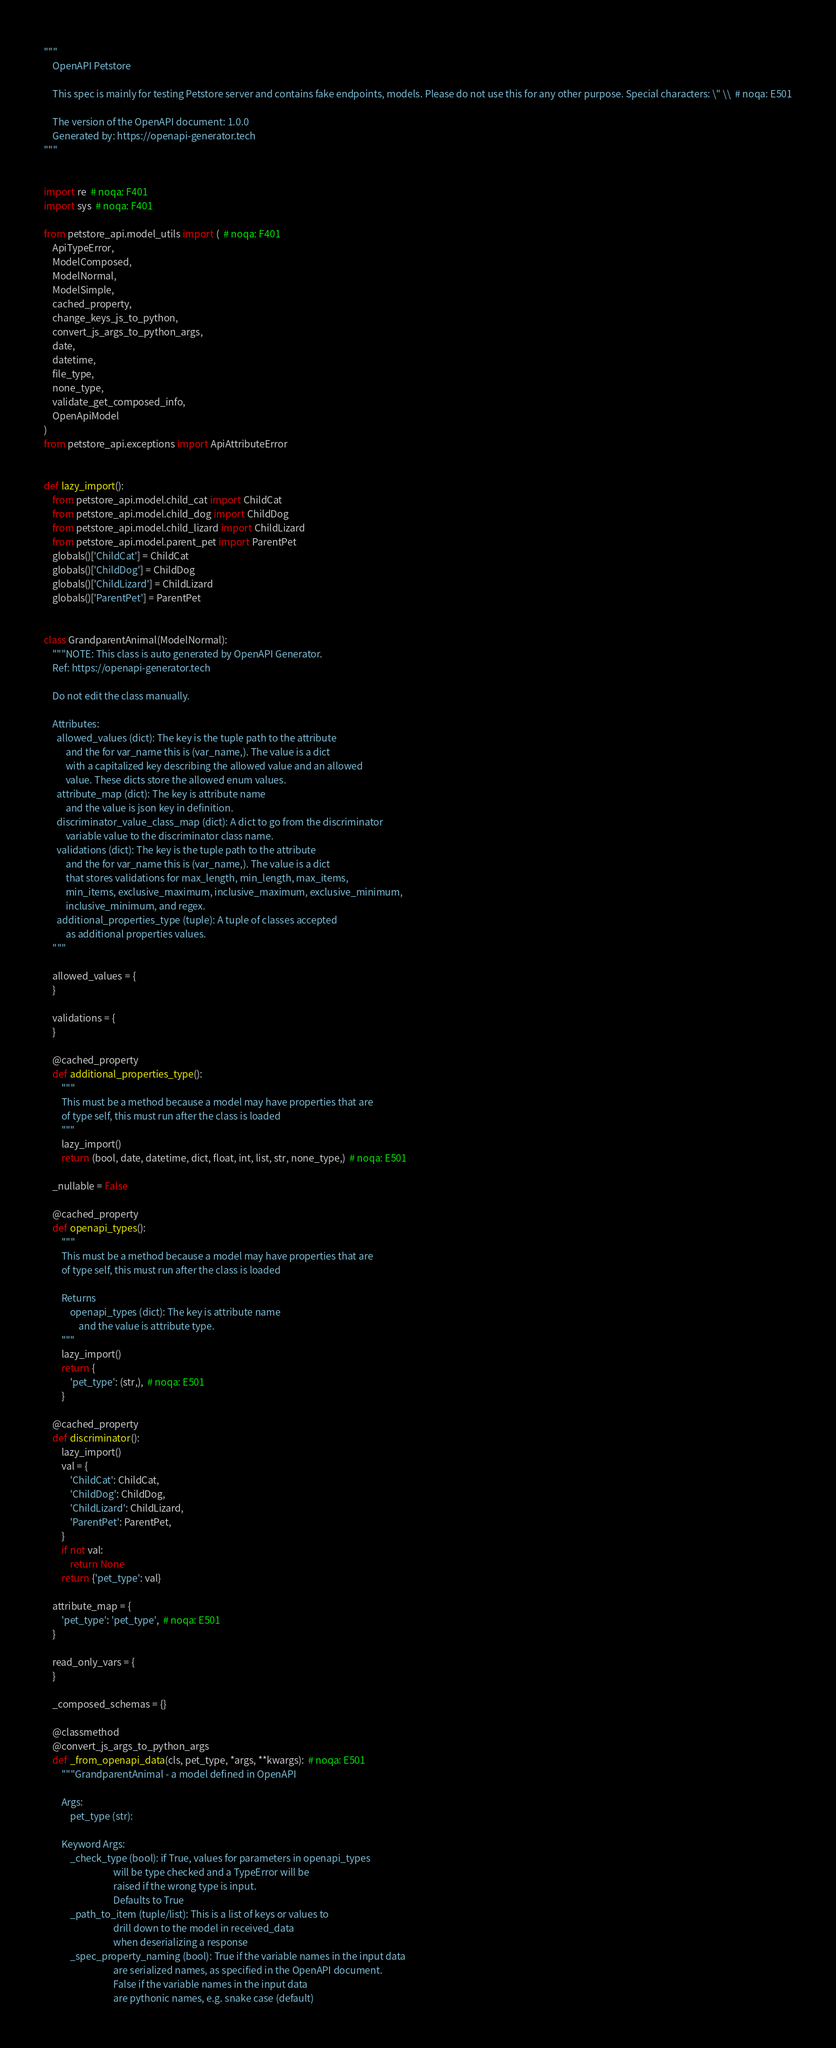<code> <loc_0><loc_0><loc_500><loc_500><_Python_>"""
    OpenAPI Petstore

    This spec is mainly for testing Petstore server and contains fake endpoints, models. Please do not use this for any other purpose. Special characters: \" \\  # noqa: E501

    The version of the OpenAPI document: 1.0.0
    Generated by: https://openapi-generator.tech
"""


import re  # noqa: F401
import sys  # noqa: F401

from petstore_api.model_utils import (  # noqa: F401
    ApiTypeError,
    ModelComposed,
    ModelNormal,
    ModelSimple,
    cached_property,
    change_keys_js_to_python,
    convert_js_args_to_python_args,
    date,
    datetime,
    file_type,
    none_type,
    validate_get_composed_info,
    OpenApiModel
)
from petstore_api.exceptions import ApiAttributeError


def lazy_import():
    from petstore_api.model.child_cat import ChildCat
    from petstore_api.model.child_dog import ChildDog
    from petstore_api.model.child_lizard import ChildLizard
    from petstore_api.model.parent_pet import ParentPet
    globals()['ChildCat'] = ChildCat
    globals()['ChildDog'] = ChildDog
    globals()['ChildLizard'] = ChildLizard
    globals()['ParentPet'] = ParentPet


class GrandparentAnimal(ModelNormal):
    """NOTE: This class is auto generated by OpenAPI Generator.
    Ref: https://openapi-generator.tech

    Do not edit the class manually.

    Attributes:
      allowed_values (dict): The key is the tuple path to the attribute
          and the for var_name this is (var_name,). The value is a dict
          with a capitalized key describing the allowed value and an allowed
          value. These dicts store the allowed enum values.
      attribute_map (dict): The key is attribute name
          and the value is json key in definition.
      discriminator_value_class_map (dict): A dict to go from the discriminator
          variable value to the discriminator class name.
      validations (dict): The key is the tuple path to the attribute
          and the for var_name this is (var_name,). The value is a dict
          that stores validations for max_length, min_length, max_items,
          min_items, exclusive_maximum, inclusive_maximum, exclusive_minimum,
          inclusive_minimum, and regex.
      additional_properties_type (tuple): A tuple of classes accepted
          as additional properties values.
    """

    allowed_values = {
    }

    validations = {
    }

    @cached_property
    def additional_properties_type():
        """
        This must be a method because a model may have properties that are
        of type self, this must run after the class is loaded
        """
        lazy_import()
        return (bool, date, datetime, dict, float, int, list, str, none_type,)  # noqa: E501

    _nullable = False

    @cached_property
    def openapi_types():
        """
        This must be a method because a model may have properties that are
        of type self, this must run after the class is loaded

        Returns
            openapi_types (dict): The key is attribute name
                and the value is attribute type.
        """
        lazy_import()
        return {
            'pet_type': (str,),  # noqa: E501
        }

    @cached_property
    def discriminator():
        lazy_import()
        val = {
            'ChildCat': ChildCat,
            'ChildDog': ChildDog,
            'ChildLizard': ChildLizard,
            'ParentPet': ParentPet,
        }
        if not val:
            return None
        return {'pet_type': val}

    attribute_map = {
        'pet_type': 'pet_type',  # noqa: E501
    }

    read_only_vars = {
    }

    _composed_schemas = {}

    @classmethod
    @convert_js_args_to_python_args
    def _from_openapi_data(cls, pet_type, *args, **kwargs):  # noqa: E501
        """GrandparentAnimal - a model defined in OpenAPI

        Args:
            pet_type (str):

        Keyword Args:
            _check_type (bool): if True, values for parameters in openapi_types
                                will be type checked and a TypeError will be
                                raised if the wrong type is input.
                                Defaults to True
            _path_to_item (tuple/list): This is a list of keys or values to
                                drill down to the model in received_data
                                when deserializing a response
            _spec_property_naming (bool): True if the variable names in the input data
                                are serialized names, as specified in the OpenAPI document.
                                False if the variable names in the input data
                                are pythonic names, e.g. snake case (default)</code> 